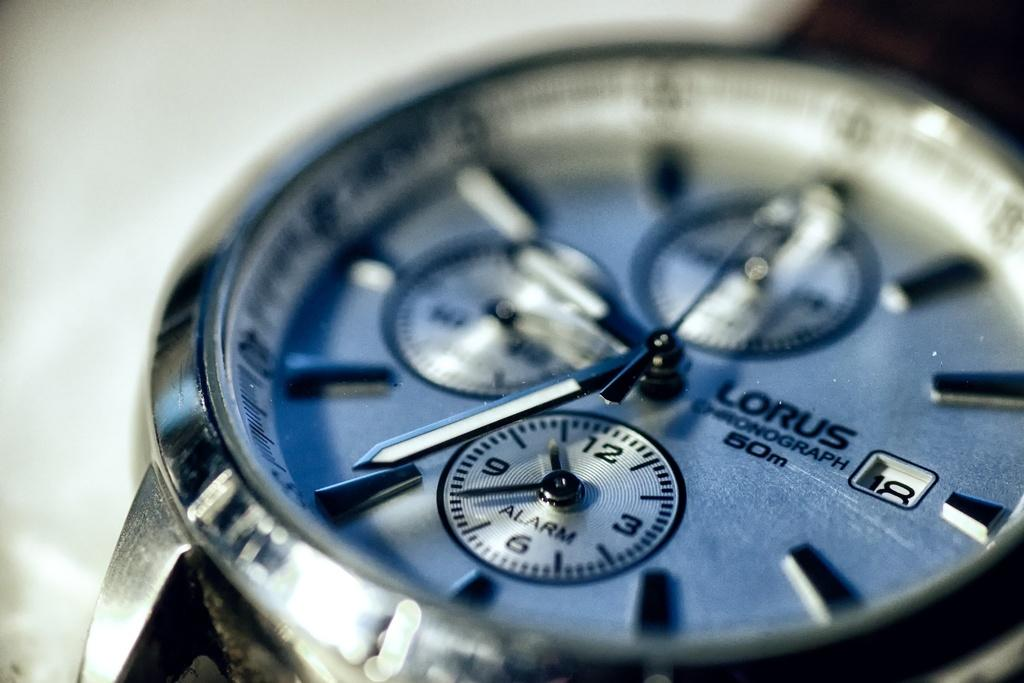<image>
Create a compact narrative representing the image presented. Close up of a Lorus watch which has three smaller clock faces in it. 